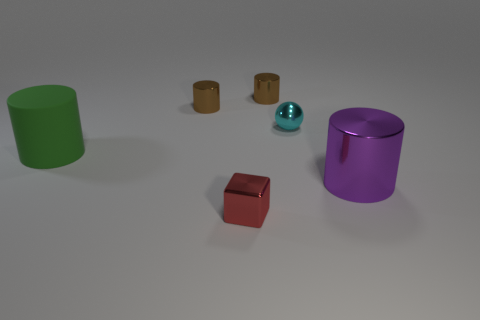Subtract all brown blocks. How many brown cylinders are left? 2 Subtract all green rubber cylinders. How many cylinders are left? 3 Subtract all green cylinders. How many cylinders are left? 3 Subtract all blue cylinders. Subtract all green spheres. How many cylinders are left? 4 Add 2 small green matte cylinders. How many objects exist? 8 Subtract all balls. How many objects are left? 5 Add 3 small red metallic cubes. How many small red metallic cubes exist? 4 Subtract 0 gray cubes. How many objects are left? 6 Subtract all tiny cyan metal things. Subtract all purple metallic cylinders. How many objects are left? 4 Add 3 red metallic blocks. How many red metallic blocks are left? 4 